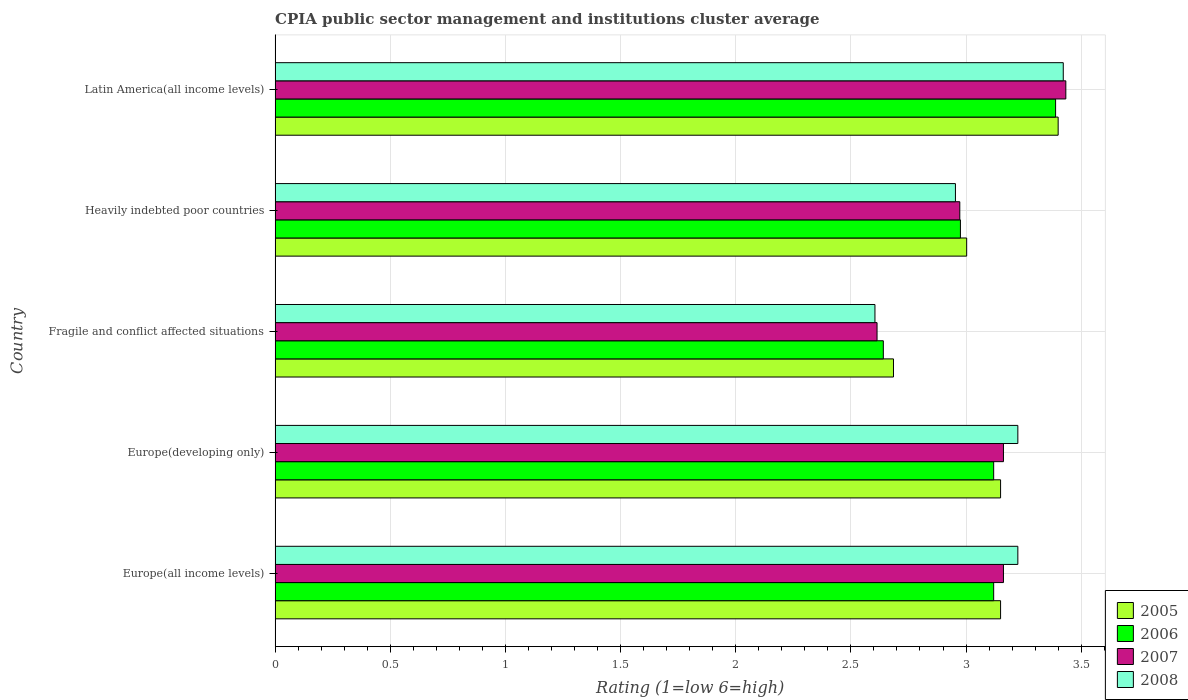How many different coloured bars are there?
Give a very brief answer. 4. How many bars are there on the 4th tick from the top?
Ensure brevity in your answer.  4. What is the label of the 3rd group of bars from the top?
Keep it short and to the point. Fragile and conflict affected situations. In how many cases, is the number of bars for a given country not equal to the number of legend labels?
Make the answer very short. 0. What is the CPIA rating in 2008 in Europe(developing only)?
Ensure brevity in your answer.  3.23. Across all countries, what is the maximum CPIA rating in 2007?
Provide a short and direct response. 3.43. Across all countries, what is the minimum CPIA rating in 2008?
Make the answer very short. 2.6. In which country was the CPIA rating in 2005 maximum?
Your answer should be compact. Latin America(all income levels). In which country was the CPIA rating in 2007 minimum?
Your response must be concise. Fragile and conflict affected situations. What is the total CPIA rating in 2005 in the graph?
Offer a terse response. 15.39. What is the difference between the CPIA rating in 2008 in Europe(all income levels) and that in Heavily indebted poor countries?
Ensure brevity in your answer.  0.27. What is the difference between the CPIA rating in 2007 in Heavily indebted poor countries and the CPIA rating in 2006 in Latin America(all income levels)?
Offer a terse response. -0.42. What is the average CPIA rating in 2006 per country?
Offer a terse response. 3.05. What is the difference between the CPIA rating in 2007 and CPIA rating in 2006 in Europe(developing only)?
Keep it short and to the point. 0.04. In how many countries, is the CPIA rating in 2008 greater than 1.6 ?
Offer a terse response. 5. What is the ratio of the CPIA rating in 2005 in Heavily indebted poor countries to that in Latin America(all income levels)?
Provide a short and direct response. 0.88. What is the difference between the highest and the second highest CPIA rating in 2008?
Keep it short and to the point. 0.2. What is the difference between the highest and the lowest CPIA rating in 2005?
Ensure brevity in your answer.  0.71. In how many countries, is the CPIA rating in 2008 greater than the average CPIA rating in 2008 taken over all countries?
Your answer should be very brief. 3. Is it the case that in every country, the sum of the CPIA rating in 2005 and CPIA rating in 2007 is greater than the sum of CPIA rating in 2006 and CPIA rating in 2008?
Make the answer very short. No. Is it the case that in every country, the sum of the CPIA rating in 2007 and CPIA rating in 2006 is greater than the CPIA rating in 2008?
Your answer should be very brief. Yes. Are all the bars in the graph horizontal?
Your answer should be compact. Yes. What is the difference between two consecutive major ticks on the X-axis?
Offer a terse response. 0.5. How many legend labels are there?
Your response must be concise. 4. What is the title of the graph?
Your answer should be compact. CPIA public sector management and institutions cluster average. Does "1981" appear as one of the legend labels in the graph?
Your answer should be very brief. No. What is the label or title of the X-axis?
Make the answer very short. Rating (1=low 6=high). What is the label or title of the Y-axis?
Your answer should be very brief. Country. What is the Rating (1=low 6=high) of 2005 in Europe(all income levels)?
Provide a succinct answer. 3.15. What is the Rating (1=low 6=high) in 2006 in Europe(all income levels)?
Provide a succinct answer. 3.12. What is the Rating (1=low 6=high) of 2007 in Europe(all income levels)?
Give a very brief answer. 3.16. What is the Rating (1=low 6=high) in 2008 in Europe(all income levels)?
Your response must be concise. 3.23. What is the Rating (1=low 6=high) in 2005 in Europe(developing only)?
Make the answer very short. 3.15. What is the Rating (1=low 6=high) of 2006 in Europe(developing only)?
Your answer should be compact. 3.12. What is the Rating (1=low 6=high) of 2007 in Europe(developing only)?
Give a very brief answer. 3.16. What is the Rating (1=low 6=high) in 2008 in Europe(developing only)?
Provide a short and direct response. 3.23. What is the Rating (1=low 6=high) of 2005 in Fragile and conflict affected situations?
Your answer should be very brief. 2.69. What is the Rating (1=low 6=high) of 2006 in Fragile and conflict affected situations?
Provide a succinct answer. 2.64. What is the Rating (1=low 6=high) in 2007 in Fragile and conflict affected situations?
Give a very brief answer. 2.61. What is the Rating (1=low 6=high) of 2008 in Fragile and conflict affected situations?
Ensure brevity in your answer.  2.6. What is the Rating (1=low 6=high) of 2005 in Heavily indebted poor countries?
Keep it short and to the point. 3. What is the Rating (1=low 6=high) in 2006 in Heavily indebted poor countries?
Your answer should be very brief. 2.98. What is the Rating (1=low 6=high) in 2007 in Heavily indebted poor countries?
Ensure brevity in your answer.  2.97. What is the Rating (1=low 6=high) of 2008 in Heavily indebted poor countries?
Give a very brief answer. 2.95. What is the Rating (1=low 6=high) in 2005 in Latin America(all income levels)?
Your answer should be compact. 3.4. What is the Rating (1=low 6=high) in 2006 in Latin America(all income levels)?
Provide a short and direct response. 3.39. What is the Rating (1=low 6=high) in 2007 in Latin America(all income levels)?
Offer a very short reply. 3.43. What is the Rating (1=low 6=high) of 2008 in Latin America(all income levels)?
Your answer should be compact. 3.42. Across all countries, what is the maximum Rating (1=low 6=high) of 2006?
Keep it short and to the point. 3.39. Across all countries, what is the maximum Rating (1=low 6=high) in 2007?
Offer a very short reply. 3.43. Across all countries, what is the maximum Rating (1=low 6=high) of 2008?
Ensure brevity in your answer.  3.42. Across all countries, what is the minimum Rating (1=low 6=high) of 2005?
Offer a very short reply. 2.69. Across all countries, what is the minimum Rating (1=low 6=high) in 2006?
Provide a short and direct response. 2.64. Across all countries, what is the minimum Rating (1=low 6=high) in 2007?
Provide a succinct answer. 2.61. Across all countries, what is the minimum Rating (1=low 6=high) in 2008?
Offer a very short reply. 2.6. What is the total Rating (1=low 6=high) of 2005 in the graph?
Your answer should be compact. 15.39. What is the total Rating (1=low 6=high) of 2006 in the graph?
Your answer should be very brief. 15.25. What is the total Rating (1=low 6=high) in 2007 in the graph?
Your answer should be very brief. 15.34. What is the total Rating (1=low 6=high) of 2008 in the graph?
Keep it short and to the point. 15.43. What is the difference between the Rating (1=low 6=high) in 2005 in Europe(all income levels) and that in Europe(developing only)?
Your answer should be very brief. 0. What is the difference between the Rating (1=low 6=high) in 2007 in Europe(all income levels) and that in Europe(developing only)?
Offer a very short reply. 0. What is the difference between the Rating (1=low 6=high) of 2008 in Europe(all income levels) and that in Europe(developing only)?
Offer a very short reply. 0. What is the difference between the Rating (1=low 6=high) of 2005 in Europe(all income levels) and that in Fragile and conflict affected situations?
Make the answer very short. 0.47. What is the difference between the Rating (1=low 6=high) in 2006 in Europe(all income levels) and that in Fragile and conflict affected situations?
Offer a terse response. 0.48. What is the difference between the Rating (1=low 6=high) in 2007 in Europe(all income levels) and that in Fragile and conflict affected situations?
Your response must be concise. 0.55. What is the difference between the Rating (1=low 6=high) in 2008 in Europe(all income levels) and that in Fragile and conflict affected situations?
Your answer should be very brief. 0.62. What is the difference between the Rating (1=low 6=high) of 2005 in Europe(all income levels) and that in Heavily indebted poor countries?
Make the answer very short. 0.15. What is the difference between the Rating (1=low 6=high) of 2006 in Europe(all income levels) and that in Heavily indebted poor countries?
Make the answer very short. 0.14. What is the difference between the Rating (1=low 6=high) of 2007 in Europe(all income levels) and that in Heavily indebted poor countries?
Give a very brief answer. 0.19. What is the difference between the Rating (1=low 6=high) of 2008 in Europe(all income levels) and that in Heavily indebted poor countries?
Ensure brevity in your answer.  0.27. What is the difference between the Rating (1=low 6=high) in 2006 in Europe(all income levels) and that in Latin America(all income levels)?
Offer a very short reply. -0.27. What is the difference between the Rating (1=low 6=high) of 2007 in Europe(all income levels) and that in Latin America(all income levels)?
Offer a very short reply. -0.27. What is the difference between the Rating (1=low 6=high) in 2008 in Europe(all income levels) and that in Latin America(all income levels)?
Give a very brief answer. -0.2. What is the difference between the Rating (1=low 6=high) of 2005 in Europe(developing only) and that in Fragile and conflict affected situations?
Keep it short and to the point. 0.47. What is the difference between the Rating (1=low 6=high) in 2006 in Europe(developing only) and that in Fragile and conflict affected situations?
Provide a short and direct response. 0.48. What is the difference between the Rating (1=low 6=high) in 2007 in Europe(developing only) and that in Fragile and conflict affected situations?
Your answer should be very brief. 0.55. What is the difference between the Rating (1=low 6=high) in 2008 in Europe(developing only) and that in Fragile and conflict affected situations?
Offer a very short reply. 0.62. What is the difference between the Rating (1=low 6=high) of 2005 in Europe(developing only) and that in Heavily indebted poor countries?
Provide a succinct answer. 0.15. What is the difference between the Rating (1=low 6=high) in 2006 in Europe(developing only) and that in Heavily indebted poor countries?
Offer a terse response. 0.14. What is the difference between the Rating (1=low 6=high) of 2007 in Europe(developing only) and that in Heavily indebted poor countries?
Give a very brief answer. 0.19. What is the difference between the Rating (1=low 6=high) in 2008 in Europe(developing only) and that in Heavily indebted poor countries?
Make the answer very short. 0.27. What is the difference between the Rating (1=low 6=high) of 2005 in Europe(developing only) and that in Latin America(all income levels)?
Keep it short and to the point. -0.25. What is the difference between the Rating (1=low 6=high) of 2006 in Europe(developing only) and that in Latin America(all income levels)?
Make the answer very short. -0.27. What is the difference between the Rating (1=low 6=high) of 2007 in Europe(developing only) and that in Latin America(all income levels)?
Your answer should be compact. -0.27. What is the difference between the Rating (1=low 6=high) of 2008 in Europe(developing only) and that in Latin America(all income levels)?
Provide a short and direct response. -0.2. What is the difference between the Rating (1=low 6=high) of 2005 in Fragile and conflict affected situations and that in Heavily indebted poor countries?
Make the answer very short. -0.32. What is the difference between the Rating (1=low 6=high) in 2006 in Fragile and conflict affected situations and that in Heavily indebted poor countries?
Your answer should be very brief. -0.33. What is the difference between the Rating (1=low 6=high) of 2007 in Fragile and conflict affected situations and that in Heavily indebted poor countries?
Your answer should be very brief. -0.36. What is the difference between the Rating (1=low 6=high) in 2008 in Fragile and conflict affected situations and that in Heavily indebted poor countries?
Offer a very short reply. -0.35. What is the difference between the Rating (1=low 6=high) of 2005 in Fragile and conflict affected situations and that in Latin America(all income levels)?
Offer a terse response. -0.71. What is the difference between the Rating (1=low 6=high) of 2006 in Fragile and conflict affected situations and that in Latin America(all income levels)?
Your response must be concise. -0.75. What is the difference between the Rating (1=low 6=high) of 2007 in Fragile and conflict affected situations and that in Latin America(all income levels)?
Ensure brevity in your answer.  -0.82. What is the difference between the Rating (1=low 6=high) of 2008 in Fragile and conflict affected situations and that in Latin America(all income levels)?
Offer a terse response. -0.82. What is the difference between the Rating (1=low 6=high) in 2005 in Heavily indebted poor countries and that in Latin America(all income levels)?
Make the answer very short. -0.4. What is the difference between the Rating (1=low 6=high) of 2006 in Heavily indebted poor countries and that in Latin America(all income levels)?
Provide a succinct answer. -0.41. What is the difference between the Rating (1=low 6=high) of 2007 in Heavily indebted poor countries and that in Latin America(all income levels)?
Keep it short and to the point. -0.46. What is the difference between the Rating (1=low 6=high) of 2008 in Heavily indebted poor countries and that in Latin America(all income levels)?
Your answer should be compact. -0.47. What is the difference between the Rating (1=low 6=high) in 2005 in Europe(all income levels) and the Rating (1=low 6=high) in 2007 in Europe(developing only)?
Offer a very short reply. -0.01. What is the difference between the Rating (1=low 6=high) in 2005 in Europe(all income levels) and the Rating (1=low 6=high) in 2008 in Europe(developing only)?
Your answer should be compact. -0.07. What is the difference between the Rating (1=low 6=high) in 2006 in Europe(all income levels) and the Rating (1=low 6=high) in 2007 in Europe(developing only)?
Offer a very short reply. -0.04. What is the difference between the Rating (1=low 6=high) in 2006 in Europe(all income levels) and the Rating (1=low 6=high) in 2008 in Europe(developing only)?
Keep it short and to the point. -0.1. What is the difference between the Rating (1=low 6=high) in 2007 in Europe(all income levels) and the Rating (1=low 6=high) in 2008 in Europe(developing only)?
Your response must be concise. -0.06. What is the difference between the Rating (1=low 6=high) in 2005 in Europe(all income levels) and the Rating (1=low 6=high) in 2006 in Fragile and conflict affected situations?
Your answer should be compact. 0.51. What is the difference between the Rating (1=low 6=high) of 2005 in Europe(all income levels) and the Rating (1=low 6=high) of 2007 in Fragile and conflict affected situations?
Ensure brevity in your answer.  0.54. What is the difference between the Rating (1=low 6=high) of 2005 in Europe(all income levels) and the Rating (1=low 6=high) of 2008 in Fragile and conflict affected situations?
Keep it short and to the point. 0.55. What is the difference between the Rating (1=low 6=high) in 2006 in Europe(all income levels) and the Rating (1=low 6=high) in 2007 in Fragile and conflict affected situations?
Provide a short and direct response. 0.51. What is the difference between the Rating (1=low 6=high) in 2006 in Europe(all income levels) and the Rating (1=low 6=high) in 2008 in Fragile and conflict affected situations?
Ensure brevity in your answer.  0.52. What is the difference between the Rating (1=low 6=high) in 2007 in Europe(all income levels) and the Rating (1=low 6=high) in 2008 in Fragile and conflict affected situations?
Provide a succinct answer. 0.56. What is the difference between the Rating (1=low 6=high) of 2005 in Europe(all income levels) and the Rating (1=low 6=high) of 2006 in Heavily indebted poor countries?
Your response must be concise. 0.17. What is the difference between the Rating (1=low 6=high) of 2005 in Europe(all income levels) and the Rating (1=low 6=high) of 2007 in Heavily indebted poor countries?
Provide a succinct answer. 0.18. What is the difference between the Rating (1=low 6=high) of 2005 in Europe(all income levels) and the Rating (1=low 6=high) of 2008 in Heavily indebted poor countries?
Your answer should be very brief. 0.2. What is the difference between the Rating (1=low 6=high) in 2006 in Europe(all income levels) and the Rating (1=low 6=high) in 2007 in Heavily indebted poor countries?
Provide a short and direct response. 0.15. What is the difference between the Rating (1=low 6=high) in 2006 in Europe(all income levels) and the Rating (1=low 6=high) in 2008 in Heavily indebted poor countries?
Provide a short and direct response. 0.17. What is the difference between the Rating (1=low 6=high) of 2007 in Europe(all income levels) and the Rating (1=low 6=high) of 2008 in Heavily indebted poor countries?
Make the answer very short. 0.21. What is the difference between the Rating (1=low 6=high) of 2005 in Europe(all income levels) and the Rating (1=low 6=high) of 2006 in Latin America(all income levels)?
Give a very brief answer. -0.24. What is the difference between the Rating (1=low 6=high) in 2005 in Europe(all income levels) and the Rating (1=low 6=high) in 2007 in Latin America(all income levels)?
Ensure brevity in your answer.  -0.28. What is the difference between the Rating (1=low 6=high) of 2005 in Europe(all income levels) and the Rating (1=low 6=high) of 2008 in Latin America(all income levels)?
Offer a very short reply. -0.27. What is the difference between the Rating (1=low 6=high) in 2006 in Europe(all income levels) and the Rating (1=low 6=high) in 2007 in Latin America(all income levels)?
Offer a terse response. -0.31. What is the difference between the Rating (1=low 6=high) in 2006 in Europe(all income levels) and the Rating (1=low 6=high) in 2008 in Latin America(all income levels)?
Ensure brevity in your answer.  -0.3. What is the difference between the Rating (1=low 6=high) of 2007 in Europe(all income levels) and the Rating (1=low 6=high) of 2008 in Latin America(all income levels)?
Provide a short and direct response. -0.26. What is the difference between the Rating (1=low 6=high) in 2005 in Europe(developing only) and the Rating (1=low 6=high) in 2006 in Fragile and conflict affected situations?
Your response must be concise. 0.51. What is the difference between the Rating (1=low 6=high) of 2005 in Europe(developing only) and the Rating (1=low 6=high) of 2007 in Fragile and conflict affected situations?
Offer a terse response. 0.54. What is the difference between the Rating (1=low 6=high) of 2005 in Europe(developing only) and the Rating (1=low 6=high) of 2008 in Fragile and conflict affected situations?
Offer a terse response. 0.55. What is the difference between the Rating (1=low 6=high) of 2006 in Europe(developing only) and the Rating (1=low 6=high) of 2007 in Fragile and conflict affected situations?
Offer a very short reply. 0.51. What is the difference between the Rating (1=low 6=high) of 2006 in Europe(developing only) and the Rating (1=low 6=high) of 2008 in Fragile and conflict affected situations?
Provide a short and direct response. 0.52. What is the difference between the Rating (1=low 6=high) of 2007 in Europe(developing only) and the Rating (1=low 6=high) of 2008 in Fragile and conflict affected situations?
Provide a succinct answer. 0.56. What is the difference between the Rating (1=low 6=high) of 2005 in Europe(developing only) and the Rating (1=low 6=high) of 2006 in Heavily indebted poor countries?
Your answer should be compact. 0.17. What is the difference between the Rating (1=low 6=high) of 2005 in Europe(developing only) and the Rating (1=low 6=high) of 2007 in Heavily indebted poor countries?
Give a very brief answer. 0.18. What is the difference between the Rating (1=low 6=high) in 2005 in Europe(developing only) and the Rating (1=low 6=high) in 2008 in Heavily indebted poor countries?
Provide a short and direct response. 0.2. What is the difference between the Rating (1=low 6=high) of 2006 in Europe(developing only) and the Rating (1=low 6=high) of 2007 in Heavily indebted poor countries?
Your answer should be compact. 0.15. What is the difference between the Rating (1=low 6=high) of 2006 in Europe(developing only) and the Rating (1=low 6=high) of 2008 in Heavily indebted poor countries?
Your answer should be very brief. 0.17. What is the difference between the Rating (1=low 6=high) in 2007 in Europe(developing only) and the Rating (1=low 6=high) in 2008 in Heavily indebted poor countries?
Keep it short and to the point. 0.21. What is the difference between the Rating (1=low 6=high) in 2005 in Europe(developing only) and the Rating (1=low 6=high) in 2006 in Latin America(all income levels)?
Give a very brief answer. -0.24. What is the difference between the Rating (1=low 6=high) of 2005 in Europe(developing only) and the Rating (1=low 6=high) of 2007 in Latin America(all income levels)?
Offer a terse response. -0.28. What is the difference between the Rating (1=low 6=high) of 2005 in Europe(developing only) and the Rating (1=low 6=high) of 2008 in Latin America(all income levels)?
Your answer should be compact. -0.27. What is the difference between the Rating (1=low 6=high) of 2006 in Europe(developing only) and the Rating (1=low 6=high) of 2007 in Latin America(all income levels)?
Make the answer very short. -0.31. What is the difference between the Rating (1=low 6=high) in 2006 in Europe(developing only) and the Rating (1=low 6=high) in 2008 in Latin America(all income levels)?
Your response must be concise. -0.3. What is the difference between the Rating (1=low 6=high) of 2007 in Europe(developing only) and the Rating (1=low 6=high) of 2008 in Latin America(all income levels)?
Your response must be concise. -0.26. What is the difference between the Rating (1=low 6=high) of 2005 in Fragile and conflict affected situations and the Rating (1=low 6=high) of 2006 in Heavily indebted poor countries?
Your response must be concise. -0.29. What is the difference between the Rating (1=low 6=high) in 2005 in Fragile and conflict affected situations and the Rating (1=low 6=high) in 2007 in Heavily indebted poor countries?
Give a very brief answer. -0.29. What is the difference between the Rating (1=low 6=high) of 2005 in Fragile and conflict affected situations and the Rating (1=low 6=high) of 2008 in Heavily indebted poor countries?
Provide a succinct answer. -0.27. What is the difference between the Rating (1=low 6=high) of 2006 in Fragile and conflict affected situations and the Rating (1=low 6=high) of 2007 in Heavily indebted poor countries?
Offer a very short reply. -0.33. What is the difference between the Rating (1=low 6=high) in 2006 in Fragile and conflict affected situations and the Rating (1=low 6=high) in 2008 in Heavily indebted poor countries?
Give a very brief answer. -0.31. What is the difference between the Rating (1=low 6=high) of 2007 in Fragile and conflict affected situations and the Rating (1=low 6=high) of 2008 in Heavily indebted poor countries?
Offer a terse response. -0.34. What is the difference between the Rating (1=low 6=high) in 2005 in Fragile and conflict affected situations and the Rating (1=low 6=high) in 2006 in Latin America(all income levels)?
Keep it short and to the point. -0.7. What is the difference between the Rating (1=low 6=high) of 2005 in Fragile and conflict affected situations and the Rating (1=low 6=high) of 2007 in Latin America(all income levels)?
Your response must be concise. -0.75. What is the difference between the Rating (1=low 6=high) in 2005 in Fragile and conflict affected situations and the Rating (1=low 6=high) in 2008 in Latin America(all income levels)?
Provide a short and direct response. -0.74. What is the difference between the Rating (1=low 6=high) of 2006 in Fragile and conflict affected situations and the Rating (1=low 6=high) of 2007 in Latin America(all income levels)?
Offer a terse response. -0.79. What is the difference between the Rating (1=low 6=high) of 2006 in Fragile and conflict affected situations and the Rating (1=low 6=high) of 2008 in Latin America(all income levels)?
Your response must be concise. -0.78. What is the difference between the Rating (1=low 6=high) in 2007 in Fragile and conflict affected situations and the Rating (1=low 6=high) in 2008 in Latin America(all income levels)?
Offer a terse response. -0.81. What is the difference between the Rating (1=low 6=high) in 2005 in Heavily indebted poor countries and the Rating (1=low 6=high) in 2006 in Latin America(all income levels)?
Your response must be concise. -0.39. What is the difference between the Rating (1=low 6=high) in 2005 in Heavily indebted poor countries and the Rating (1=low 6=high) in 2007 in Latin America(all income levels)?
Make the answer very short. -0.43. What is the difference between the Rating (1=low 6=high) in 2005 in Heavily indebted poor countries and the Rating (1=low 6=high) in 2008 in Latin America(all income levels)?
Your response must be concise. -0.42. What is the difference between the Rating (1=low 6=high) in 2006 in Heavily indebted poor countries and the Rating (1=low 6=high) in 2007 in Latin America(all income levels)?
Ensure brevity in your answer.  -0.46. What is the difference between the Rating (1=low 6=high) in 2006 in Heavily indebted poor countries and the Rating (1=low 6=high) in 2008 in Latin America(all income levels)?
Give a very brief answer. -0.45. What is the difference between the Rating (1=low 6=high) in 2007 in Heavily indebted poor countries and the Rating (1=low 6=high) in 2008 in Latin America(all income levels)?
Give a very brief answer. -0.45. What is the average Rating (1=low 6=high) in 2005 per country?
Your answer should be compact. 3.08. What is the average Rating (1=low 6=high) of 2006 per country?
Offer a terse response. 3.05. What is the average Rating (1=low 6=high) of 2007 per country?
Your answer should be very brief. 3.07. What is the average Rating (1=low 6=high) of 2008 per country?
Your answer should be very brief. 3.09. What is the difference between the Rating (1=low 6=high) of 2005 and Rating (1=low 6=high) of 2007 in Europe(all income levels)?
Give a very brief answer. -0.01. What is the difference between the Rating (1=low 6=high) of 2005 and Rating (1=low 6=high) of 2008 in Europe(all income levels)?
Offer a terse response. -0.07. What is the difference between the Rating (1=low 6=high) in 2006 and Rating (1=low 6=high) in 2007 in Europe(all income levels)?
Provide a short and direct response. -0.04. What is the difference between the Rating (1=low 6=high) in 2006 and Rating (1=low 6=high) in 2008 in Europe(all income levels)?
Ensure brevity in your answer.  -0.1. What is the difference between the Rating (1=low 6=high) of 2007 and Rating (1=low 6=high) of 2008 in Europe(all income levels)?
Provide a short and direct response. -0.06. What is the difference between the Rating (1=low 6=high) in 2005 and Rating (1=low 6=high) in 2006 in Europe(developing only)?
Ensure brevity in your answer.  0.03. What is the difference between the Rating (1=low 6=high) of 2005 and Rating (1=low 6=high) of 2007 in Europe(developing only)?
Ensure brevity in your answer.  -0.01. What is the difference between the Rating (1=low 6=high) of 2005 and Rating (1=low 6=high) of 2008 in Europe(developing only)?
Offer a very short reply. -0.07. What is the difference between the Rating (1=low 6=high) in 2006 and Rating (1=low 6=high) in 2007 in Europe(developing only)?
Your answer should be very brief. -0.04. What is the difference between the Rating (1=low 6=high) of 2006 and Rating (1=low 6=high) of 2008 in Europe(developing only)?
Your answer should be very brief. -0.1. What is the difference between the Rating (1=low 6=high) in 2007 and Rating (1=low 6=high) in 2008 in Europe(developing only)?
Your answer should be very brief. -0.06. What is the difference between the Rating (1=low 6=high) of 2005 and Rating (1=low 6=high) of 2006 in Fragile and conflict affected situations?
Your response must be concise. 0.04. What is the difference between the Rating (1=low 6=high) of 2005 and Rating (1=low 6=high) of 2007 in Fragile and conflict affected situations?
Provide a short and direct response. 0.07. What is the difference between the Rating (1=low 6=high) of 2005 and Rating (1=low 6=high) of 2008 in Fragile and conflict affected situations?
Give a very brief answer. 0.08. What is the difference between the Rating (1=low 6=high) of 2006 and Rating (1=low 6=high) of 2007 in Fragile and conflict affected situations?
Provide a short and direct response. 0.03. What is the difference between the Rating (1=low 6=high) in 2006 and Rating (1=low 6=high) in 2008 in Fragile and conflict affected situations?
Your answer should be compact. 0.04. What is the difference between the Rating (1=low 6=high) in 2007 and Rating (1=low 6=high) in 2008 in Fragile and conflict affected situations?
Your response must be concise. 0.01. What is the difference between the Rating (1=low 6=high) in 2005 and Rating (1=low 6=high) in 2006 in Heavily indebted poor countries?
Your answer should be compact. 0.03. What is the difference between the Rating (1=low 6=high) of 2005 and Rating (1=low 6=high) of 2007 in Heavily indebted poor countries?
Your answer should be very brief. 0.03. What is the difference between the Rating (1=low 6=high) in 2005 and Rating (1=low 6=high) in 2008 in Heavily indebted poor countries?
Your answer should be very brief. 0.05. What is the difference between the Rating (1=low 6=high) in 2006 and Rating (1=low 6=high) in 2007 in Heavily indebted poor countries?
Provide a short and direct response. 0. What is the difference between the Rating (1=low 6=high) in 2006 and Rating (1=low 6=high) in 2008 in Heavily indebted poor countries?
Your response must be concise. 0.02. What is the difference between the Rating (1=low 6=high) of 2007 and Rating (1=low 6=high) of 2008 in Heavily indebted poor countries?
Provide a succinct answer. 0.02. What is the difference between the Rating (1=low 6=high) in 2005 and Rating (1=low 6=high) in 2006 in Latin America(all income levels)?
Offer a terse response. 0.01. What is the difference between the Rating (1=low 6=high) in 2005 and Rating (1=low 6=high) in 2007 in Latin America(all income levels)?
Make the answer very short. -0.03. What is the difference between the Rating (1=low 6=high) in 2005 and Rating (1=low 6=high) in 2008 in Latin America(all income levels)?
Make the answer very short. -0.02. What is the difference between the Rating (1=low 6=high) of 2006 and Rating (1=low 6=high) of 2007 in Latin America(all income levels)?
Ensure brevity in your answer.  -0.04. What is the difference between the Rating (1=low 6=high) of 2006 and Rating (1=low 6=high) of 2008 in Latin America(all income levels)?
Keep it short and to the point. -0.03. What is the difference between the Rating (1=low 6=high) of 2007 and Rating (1=low 6=high) of 2008 in Latin America(all income levels)?
Provide a short and direct response. 0.01. What is the ratio of the Rating (1=low 6=high) in 2007 in Europe(all income levels) to that in Europe(developing only)?
Give a very brief answer. 1. What is the ratio of the Rating (1=low 6=high) in 2008 in Europe(all income levels) to that in Europe(developing only)?
Offer a terse response. 1. What is the ratio of the Rating (1=low 6=high) in 2005 in Europe(all income levels) to that in Fragile and conflict affected situations?
Keep it short and to the point. 1.17. What is the ratio of the Rating (1=low 6=high) in 2006 in Europe(all income levels) to that in Fragile and conflict affected situations?
Provide a short and direct response. 1.18. What is the ratio of the Rating (1=low 6=high) in 2007 in Europe(all income levels) to that in Fragile and conflict affected situations?
Your answer should be compact. 1.21. What is the ratio of the Rating (1=low 6=high) in 2008 in Europe(all income levels) to that in Fragile and conflict affected situations?
Your response must be concise. 1.24. What is the ratio of the Rating (1=low 6=high) in 2005 in Europe(all income levels) to that in Heavily indebted poor countries?
Your answer should be compact. 1.05. What is the ratio of the Rating (1=low 6=high) of 2006 in Europe(all income levels) to that in Heavily indebted poor countries?
Provide a succinct answer. 1.05. What is the ratio of the Rating (1=low 6=high) of 2007 in Europe(all income levels) to that in Heavily indebted poor countries?
Your response must be concise. 1.06. What is the ratio of the Rating (1=low 6=high) in 2008 in Europe(all income levels) to that in Heavily indebted poor countries?
Your answer should be compact. 1.09. What is the ratio of the Rating (1=low 6=high) of 2005 in Europe(all income levels) to that in Latin America(all income levels)?
Your answer should be compact. 0.93. What is the ratio of the Rating (1=low 6=high) of 2006 in Europe(all income levels) to that in Latin America(all income levels)?
Offer a very short reply. 0.92. What is the ratio of the Rating (1=low 6=high) in 2007 in Europe(all income levels) to that in Latin America(all income levels)?
Your response must be concise. 0.92. What is the ratio of the Rating (1=low 6=high) in 2008 in Europe(all income levels) to that in Latin America(all income levels)?
Give a very brief answer. 0.94. What is the ratio of the Rating (1=low 6=high) of 2005 in Europe(developing only) to that in Fragile and conflict affected situations?
Provide a succinct answer. 1.17. What is the ratio of the Rating (1=low 6=high) of 2006 in Europe(developing only) to that in Fragile and conflict affected situations?
Offer a terse response. 1.18. What is the ratio of the Rating (1=low 6=high) in 2007 in Europe(developing only) to that in Fragile and conflict affected situations?
Offer a terse response. 1.21. What is the ratio of the Rating (1=low 6=high) in 2008 in Europe(developing only) to that in Fragile and conflict affected situations?
Keep it short and to the point. 1.24. What is the ratio of the Rating (1=low 6=high) of 2005 in Europe(developing only) to that in Heavily indebted poor countries?
Your answer should be very brief. 1.05. What is the ratio of the Rating (1=low 6=high) in 2006 in Europe(developing only) to that in Heavily indebted poor countries?
Provide a succinct answer. 1.05. What is the ratio of the Rating (1=low 6=high) in 2007 in Europe(developing only) to that in Heavily indebted poor countries?
Offer a very short reply. 1.06. What is the ratio of the Rating (1=low 6=high) in 2008 in Europe(developing only) to that in Heavily indebted poor countries?
Make the answer very short. 1.09. What is the ratio of the Rating (1=low 6=high) in 2005 in Europe(developing only) to that in Latin America(all income levels)?
Offer a terse response. 0.93. What is the ratio of the Rating (1=low 6=high) of 2006 in Europe(developing only) to that in Latin America(all income levels)?
Your answer should be compact. 0.92. What is the ratio of the Rating (1=low 6=high) of 2007 in Europe(developing only) to that in Latin America(all income levels)?
Provide a succinct answer. 0.92. What is the ratio of the Rating (1=low 6=high) of 2008 in Europe(developing only) to that in Latin America(all income levels)?
Make the answer very short. 0.94. What is the ratio of the Rating (1=low 6=high) of 2005 in Fragile and conflict affected situations to that in Heavily indebted poor countries?
Offer a very short reply. 0.89. What is the ratio of the Rating (1=low 6=high) in 2006 in Fragile and conflict affected situations to that in Heavily indebted poor countries?
Your response must be concise. 0.89. What is the ratio of the Rating (1=low 6=high) of 2007 in Fragile and conflict affected situations to that in Heavily indebted poor countries?
Ensure brevity in your answer.  0.88. What is the ratio of the Rating (1=low 6=high) in 2008 in Fragile and conflict affected situations to that in Heavily indebted poor countries?
Your answer should be compact. 0.88. What is the ratio of the Rating (1=low 6=high) of 2005 in Fragile and conflict affected situations to that in Latin America(all income levels)?
Your response must be concise. 0.79. What is the ratio of the Rating (1=low 6=high) of 2006 in Fragile and conflict affected situations to that in Latin America(all income levels)?
Provide a succinct answer. 0.78. What is the ratio of the Rating (1=low 6=high) of 2007 in Fragile and conflict affected situations to that in Latin America(all income levels)?
Offer a terse response. 0.76. What is the ratio of the Rating (1=low 6=high) in 2008 in Fragile and conflict affected situations to that in Latin America(all income levels)?
Offer a very short reply. 0.76. What is the ratio of the Rating (1=low 6=high) in 2005 in Heavily indebted poor countries to that in Latin America(all income levels)?
Offer a terse response. 0.88. What is the ratio of the Rating (1=low 6=high) of 2006 in Heavily indebted poor countries to that in Latin America(all income levels)?
Provide a short and direct response. 0.88. What is the ratio of the Rating (1=low 6=high) in 2007 in Heavily indebted poor countries to that in Latin America(all income levels)?
Offer a terse response. 0.87. What is the ratio of the Rating (1=low 6=high) of 2008 in Heavily indebted poor countries to that in Latin America(all income levels)?
Your answer should be very brief. 0.86. What is the difference between the highest and the second highest Rating (1=low 6=high) in 2006?
Ensure brevity in your answer.  0.27. What is the difference between the highest and the second highest Rating (1=low 6=high) of 2007?
Offer a very short reply. 0.27. What is the difference between the highest and the second highest Rating (1=low 6=high) of 2008?
Offer a terse response. 0.2. What is the difference between the highest and the lowest Rating (1=low 6=high) of 2005?
Offer a terse response. 0.71. What is the difference between the highest and the lowest Rating (1=low 6=high) in 2006?
Your answer should be compact. 0.75. What is the difference between the highest and the lowest Rating (1=low 6=high) of 2007?
Offer a very short reply. 0.82. What is the difference between the highest and the lowest Rating (1=low 6=high) of 2008?
Your answer should be compact. 0.82. 